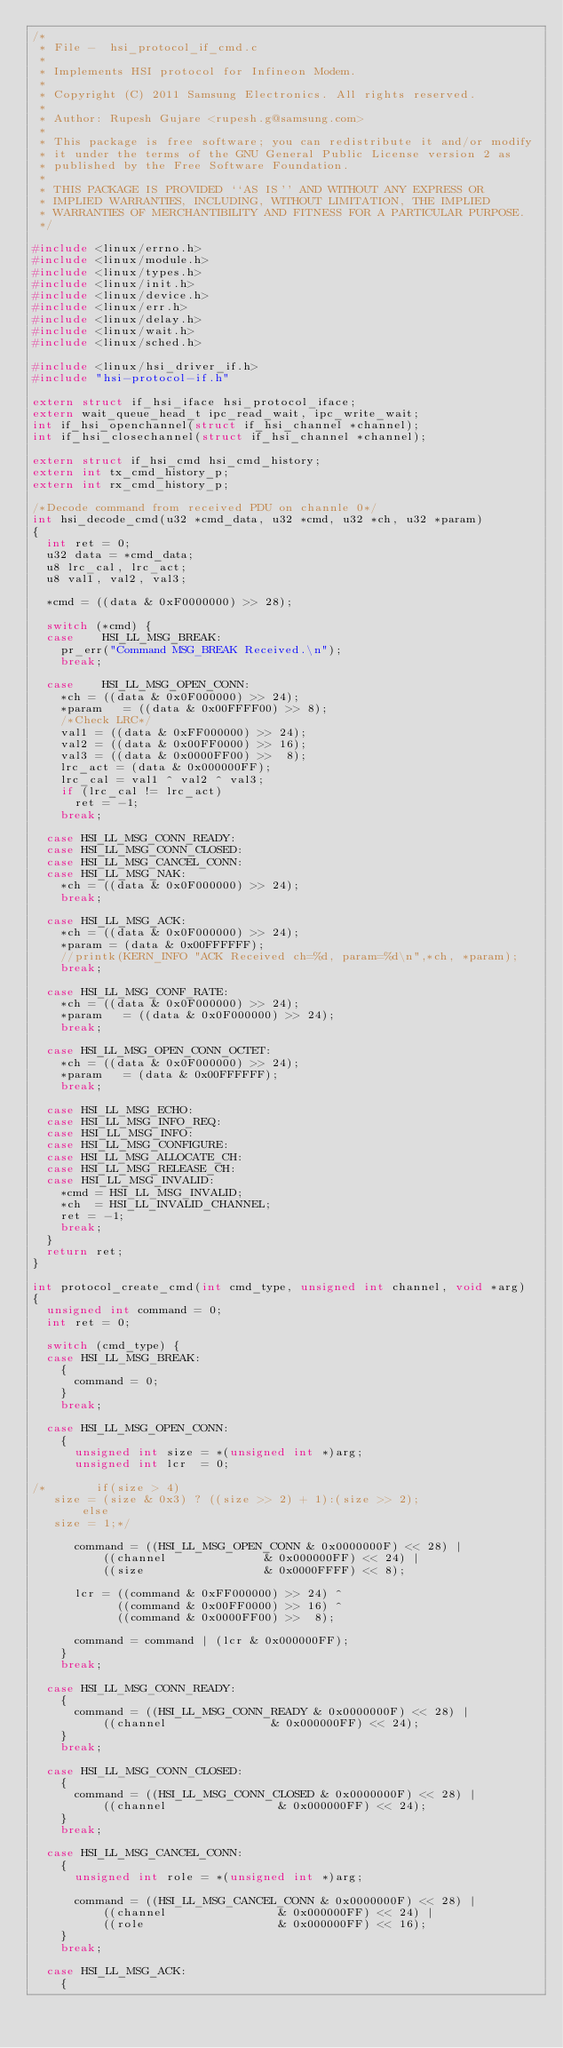Convert code to text. <code><loc_0><loc_0><loc_500><loc_500><_C_>/*
 * File -  hsi_protocol_if_cmd.c
 *
 * Implements HSI protocol for Infineon Modem.
 *
 * Copyright (C) 2011 Samsung Electronics. All rights reserved.
 *
 * Author: Rupesh Gujare <rupesh.g@samsung.com>
 *
 * This package is free software; you can redistribute it and/or modify
 * it under the terms of the GNU General Public License version 2 as
 * published by the Free Software Foundation.
 *
 * THIS PACKAGE IS PROVIDED ``AS IS'' AND WITHOUT ANY EXPRESS OR
 * IMPLIED WARRANTIES, INCLUDING, WITHOUT LIMITATION, THE IMPLIED
 * WARRANTIES OF MERCHANTIBILITY AND FITNESS FOR A PARTICULAR PURPOSE.
 */

#include <linux/errno.h>
#include <linux/module.h>
#include <linux/types.h>
#include <linux/init.h>
#include <linux/device.h>
#include <linux/err.h>
#include <linux/delay.h>
#include <linux/wait.h>
#include <linux/sched.h>

#include <linux/hsi_driver_if.h>
#include "hsi-protocol-if.h"

extern struct if_hsi_iface hsi_protocol_iface;
extern wait_queue_head_t ipc_read_wait, ipc_write_wait;
int if_hsi_openchannel(struct if_hsi_channel *channel);
int if_hsi_closechannel(struct if_hsi_channel *channel);

extern struct if_hsi_cmd hsi_cmd_history;
extern int tx_cmd_history_p;
extern int rx_cmd_history_p;

/*Decode command from received PDU on channle 0*/
int hsi_decode_cmd(u32 *cmd_data, u32 *cmd, u32 *ch, u32 *param)
{
	int ret = 0;
	u32 data = *cmd_data;
	u8 lrc_cal, lrc_act;
	u8 val1, val2, val3;

	*cmd = ((data & 0xF0000000) >> 28);

	switch (*cmd) {
	case    HSI_LL_MSG_BREAK:
		pr_err("Command MSG_BREAK Received.\n");
		break;

	case    HSI_LL_MSG_OPEN_CONN:
		*ch = ((data & 0x0F000000) >> 24);
		*param   = ((data & 0x00FFFF00) >> 8);
		/*Check LRC*/
		val1 = ((data & 0xFF000000) >> 24);
		val2 = ((data & 0x00FF0000) >> 16);
		val3 = ((data & 0x0000FF00) >>  8);
		lrc_act = (data & 0x000000FF);
		lrc_cal = val1 ^ val2 ^ val3;
		if (lrc_cal != lrc_act)
			ret = -1;
		break;

	case HSI_LL_MSG_CONN_READY:
	case HSI_LL_MSG_CONN_CLOSED:
	case HSI_LL_MSG_CANCEL_CONN:
	case HSI_LL_MSG_NAK:
		*ch = ((data & 0x0F000000) >> 24);
		break;

	case HSI_LL_MSG_ACK:
		*ch = ((data & 0x0F000000) >> 24);
		*param = (data & 0x00FFFFFF);
		//printk(KERN_INFO "ACK Received ch=%d, param=%d\n",*ch, *param);
		break;

	case HSI_LL_MSG_CONF_RATE:
		*ch = ((data & 0x0F000000) >> 24);
		*param   = ((data & 0x0F000000) >> 24);
		break;

	case HSI_LL_MSG_OPEN_CONN_OCTET:
		*ch = ((data & 0x0F000000) >> 24);
		*param   = (data & 0x00FFFFFF);
		break;

	case HSI_LL_MSG_ECHO:
	case HSI_LL_MSG_INFO_REQ:
	case HSI_LL_MSG_INFO:
	case HSI_LL_MSG_CONFIGURE:
	case HSI_LL_MSG_ALLOCATE_CH:
	case HSI_LL_MSG_RELEASE_CH:
	case HSI_LL_MSG_INVALID:
		*cmd = HSI_LL_MSG_INVALID;
		*ch  = HSI_LL_INVALID_CHANNEL;
		ret = -1;
		break;
	}
	return ret;
}

int protocol_create_cmd(int cmd_type, unsigned int channel, void *arg)
{
	unsigned int command = 0;
	int ret = 0;

	switch (cmd_type) {
	case HSI_LL_MSG_BREAK:
		{
			command = 0;
		}
		break;

	case HSI_LL_MSG_OPEN_CONN:
		{
			unsigned int size = *(unsigned int *)arg;
			unsigned int lcr  = 0;

/*       if(size > 4)
	 size = (size & 0x3) ? ((size >> 2) + 1):(size >> 2);
       else
	 size = 1;*/

			command = ((HSI_LL_MSG_OPEN_CONN & 0x0000000F) << 28) |
				  ((channel              & 0x000000FF) << 24) |
				  ((size                 & 0x0000FFFF) << 8);

			lcr = ((command & 0xFF000000) >> 24) ^
			      ((command & 0x00FF0000) >> 16) ^
			      ((command & 0x0000FF00) >>  8);

			command = command | (lcr & 0x000000FF);
		}
		break;

	case HSI_LL_MSG_CONN_READY:
		{
			command = ((HSI_LL_MSG_CONN_READY & 0x0000000F) << 28) |
				  ((channel               & 0x000000FF) << 24);
		}
		break;

	case HSI_LL_MSG_CONN_CLOSED:
		{
			command = ((HSI_LL_MSG_CONN_CLOSED & 0x0000000F) << 28) |
				  ((channel                & 0x000000FF) << 24);
		}
		break;

	case HSI_LL_MSG_CANCEL_CONN:
		{
			unsigned int role = *(unsigned int *)arg;

			command = ((HSI_LL_MSG_CANCEL_CONN & 0x0000000F) << 28) |
				  ((channel                & 0x000000FF) << 24) |
				  ((role                   & 0x000000FF) << 16);
		}
		break;

	case HSI_LL_MSG_ACK:
		{</code> 